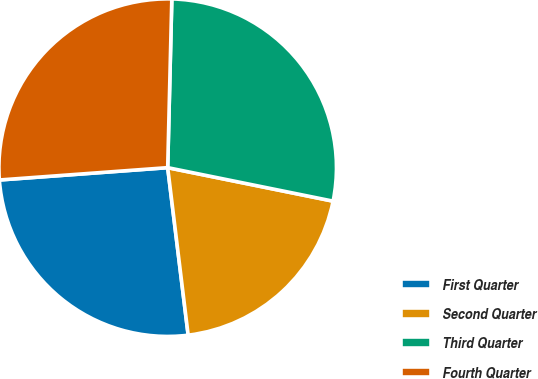Convert chart. <chart><loc_0><loc_0><loc_500><loc_500><pie_chart><fcel>First Quarter<fcel>Second Quarter<fcel>Third Quarter<fcel>Fourth Quarter<nl><fcel>25.77%<fcel>19.88%<fcel>27.79%<fcel>26.55%<nl></chart> 